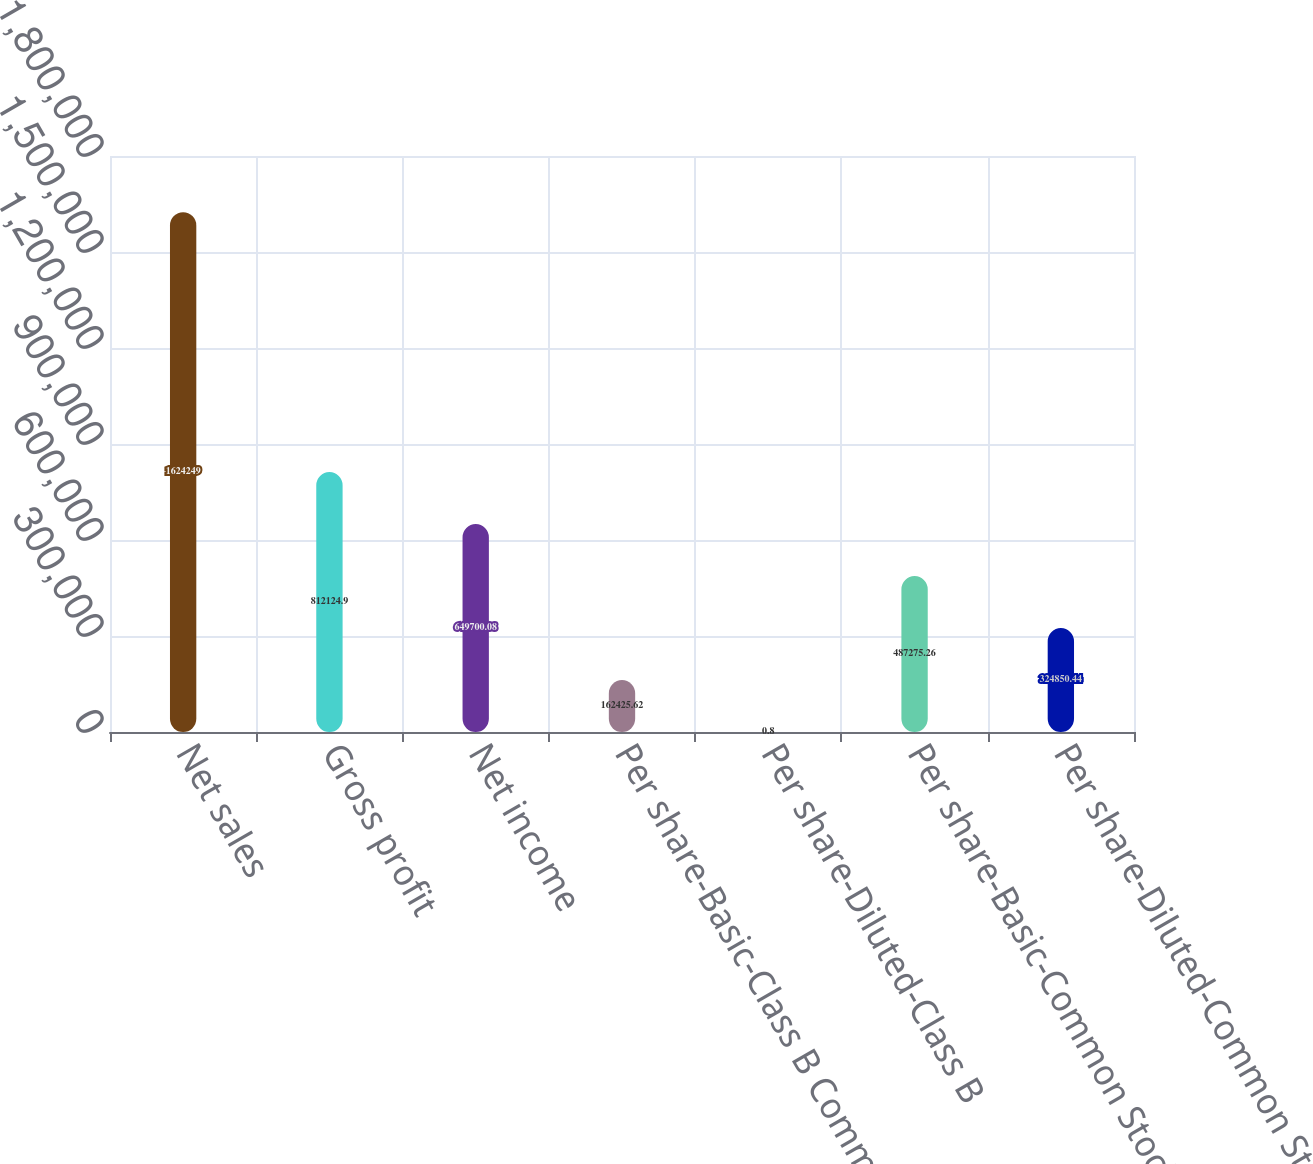Convert chart. <chart><loc_0><loc_0><loc_500><loc_500><bar_chart><fcel>Net sales<fcel>Gross profit<fcel>Net income<fcel>Per share-Basic-Class B Common<fcel>Per share-Diluted-Class B<fcel>Per share-Basic-Common Stock<fcel>Per share-Diluted-Common Stock<nl><fcel>1.62425e+06<fcel>812125<fcel>649700<fcel>162426<fcel>0.8<fcel>487275<fcel>324850<nl></chart> 